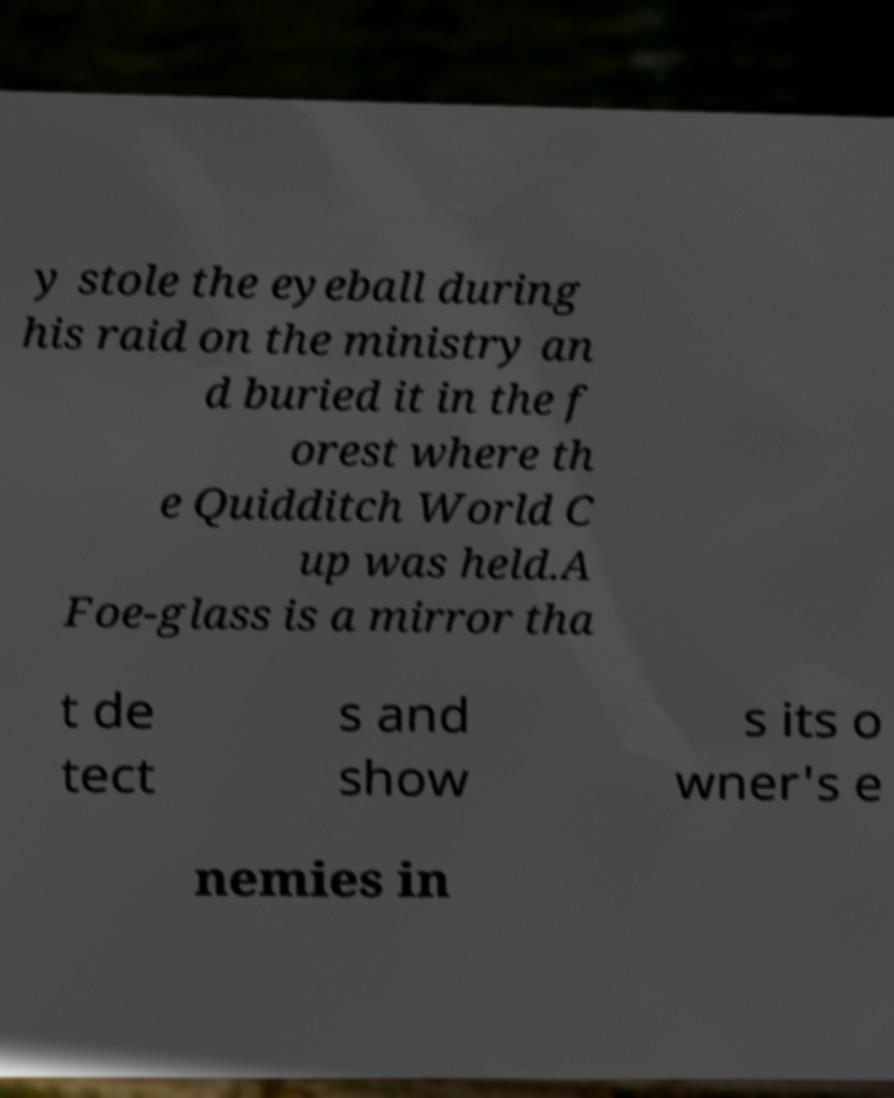Please identify and transcribe the text found in this image. y stole the eyeball during his raid on the ministry an d buried it in the f orest where th e Quidditch World C up was held.A Foe-glass is a mirror tha t de tect s and show s its o wner's e nemies in 